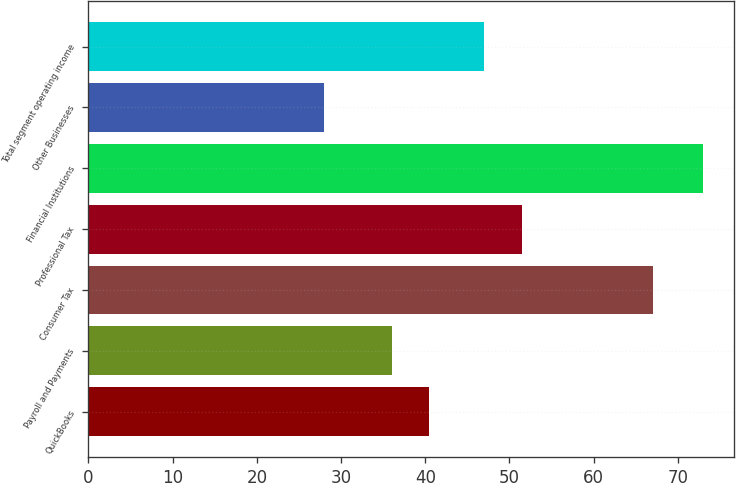Convert chart to OTSL. <chart><loc_0><loc_0><loc_500><loc_500><bar_chart><fcel>QuickBooks<fcel>Payroll and Payments<fcel>Consumer Tax<fcel>Professional Tax<fcel>Financial Institutions<fcel>Other Businesses<fcel>Total segment operating income<nl><fcel>40.5<fcel>36<fcel>67<fcel>51.5<fcel>73<fcel>28<fcel>47<nl></chart> 